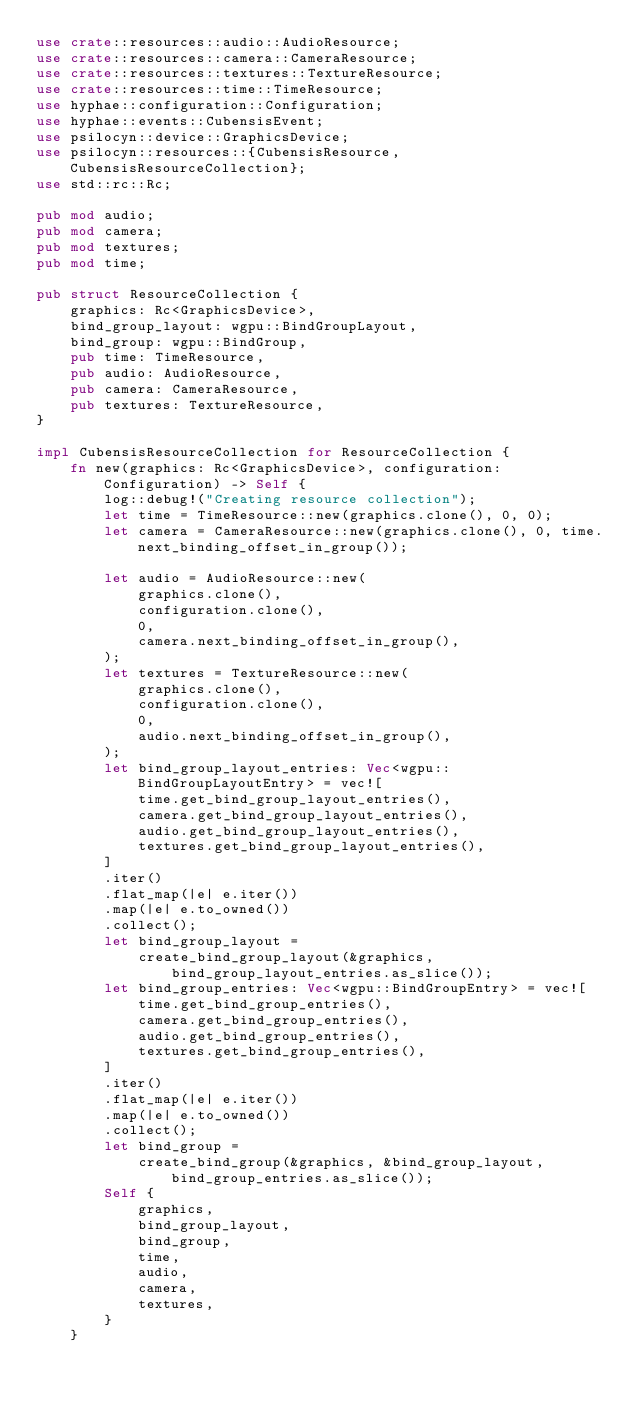<code> <loc_0><loc_0><loc_500><loc_500><_Rust_>use crate::resources::audio::AudioResource;
use crate::resources::camera::CameraResource;
use crate::resources::textures::TextureResource;
use crate::resources::time::TimeResource;
use hyphae::configuration::Configuration;
use hyphae::events::CubensisEvent;
use psilocyn::device::GraphicsDevice;
use psilocyn::resources::{CubensisResource, CubensisResourceCollection};
use std::rc::Rc;

pub mod audio;
pub mod camera;
pub mod textures;
pub mod time;

pub struct ResourceCollection {
    graphics: Rc<GraphicsDevice>,
    bind_group_layout: wgpu::BindGroupLayout,
    bind_group: wgpu::BindGroup,
    pub time: TimeResource,
    pub audio: AudioResource,
    pub camera: CameraResource,
    pub textures: TextureResource,
}

impl CubensisResourceCollection for ResourceCollection {
    fn new(graphics: Rc<GraphicsDevice>, configuration: Configuration) -> Self {
        log::debug!("Creating resource collection");
        let time = TimeResource::new(graphics.clone(), 0, 0);
        let camera = CameraResource::new(graphics.clone(), 0, time.next_binding_offset_in_group());

        let audio = AudioResource::new(
            graphics.clone(),
            configuration.clone(),
            0,
            camera.next_binding_offset_in_group(),
        );
        let textures = TextureResource::new(
            graphics.clone(),
            configuration.clone(),
            0,
            audio.next_binding_offset_in_group(),
        );
        let bind_group_layout_entries: Vec<wgpu::BindGroupLayoutEntry> = vec![
            time.get_bind_group_layout_entries(),
            camera.get_bind_group_layout_entries(),
            audio.get_bind_group_layout_entries(),
            textures.get_bind_group_layout_entries(),
        ]
        .iter()
        .flat_map(|e| e.iter())
        .map(|e| e.to_owned())
        .collect();
        let bind_group_layout =
            create_bind_group_layout(&graphics, bind_group_layout_entries.as_slice());
        let bind_group_entries: Vec<wgpu::BindGroupEntry> = vec![
            time.get_bind_group_entries(),
            camera.get_bind_group_entries(),
            audio.get_bind_group_entries(),
            textures.get_bind_group_entries(),
        ]
        .iter()
        .flat_map(|e| e.iter())
        .map(|e| e.to_owned())
        .collect();
        let bind_group =
            create_bind_group(&graphics, &bind_group_layout, bind_group_entries.as_slice());
        Self {
            graphics,
            bind_group_layout,
            bind_group,
            time,
            audio,
            camera,
            textures,
        }
    }
</code> 